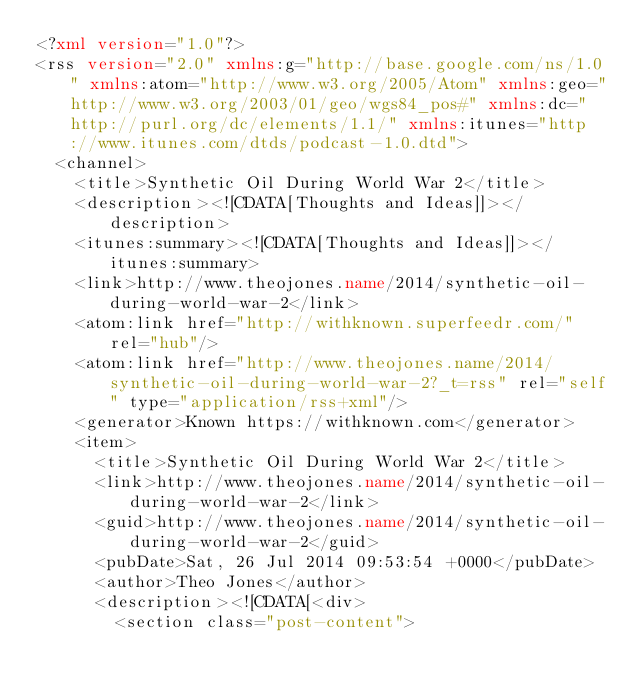Convert code to text. <code><loc_0><loc_0><loc_500><loc_500><_XML_><?xml version="1.0"?>
<rss version="2.0" xmlns:g="http://base.google.com/ns/1.0" xmlns:atom="http://www.w3.org/2005/Atom" xmlns:geo="http://www.w3.org/2003/01/geo/wgs84_pos#" xmlns:dc="http://purl.org/dc/elements/1.1/" xmlns:itunes="http://www.itunes.com/dtds/podcast-1.0.dtd">
  <channel>
    <title>Synthetic Oil During World War 2</title>
    <description><![CDATA[Thoughts and Ideas]]></description>
    <itunes:summary><![CDATA[Thoughts and Ideas]]></itunes:summary>
    <link>http://www.theojones.name/2014/synthetic-oil-during-world-war-2</link>
    <atom:link href="http://withknown.superfeedr.com/" rel="hub"/>
    <atom:link href="http://www.theojones.name/2014/synthetic-oil-during-world-war-2?_t=rss" rel="self" type="application/rss+xml"/>
    <generator>Known https://withknown.com</generator>
    <item>
      <title>Synthetic Oil During World War 2</title>
      <link>http://www.theojones.name/2014/synthetic-oil-during-world-war-2</link>
      <guid>http://www.theojones.name/2014/synthetic-oil-during-world-war-2</guid>
      <pubDate>Sat, 26 Jul 2014 09:53:54 +0000</pubDate>
      <author>Theo Jones</author>
      <description><![CDATA[<div>
        <section class="post-content"></code> 